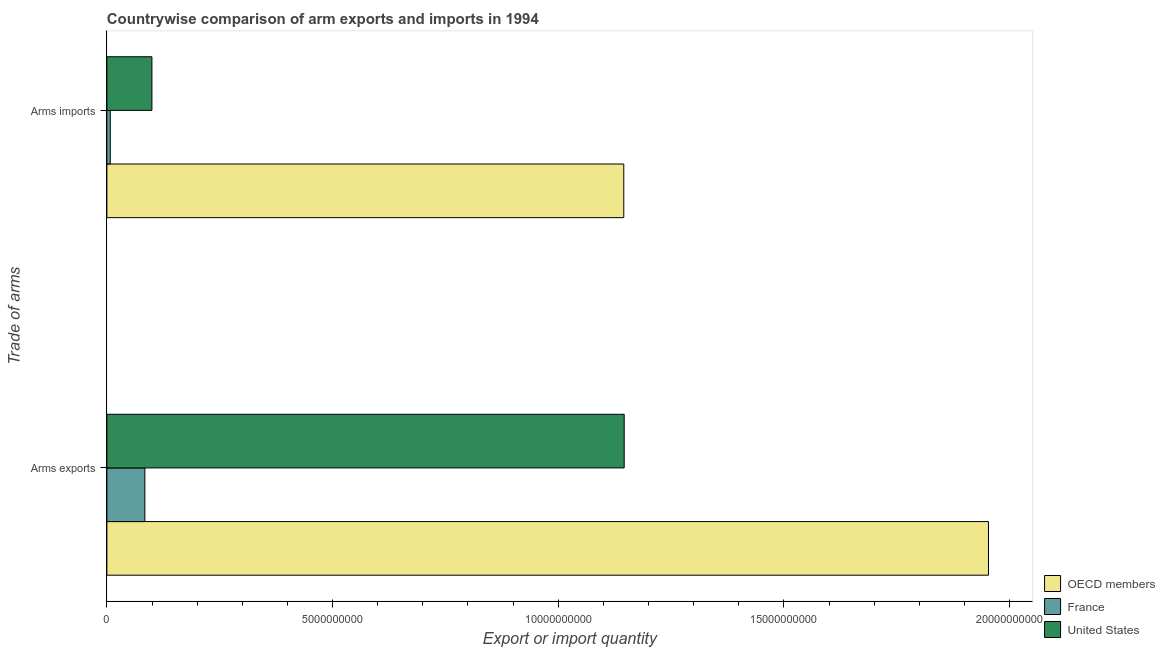How many different coloured bars are there?
Keep it short and to the point. 3. How many groups of bars are there?
Ensure brevity in your answer.  2. Are the number of bars per tick equal to the number of legend labels?
Your answer should be very brief. Yes. Are the number of bars on each tick of the Y-axis equal?
Offer a very short reply. Yes. What is the label of the 1st group of bars from the top?
Your answer should be very brief. Arms imports. What is the arms exports in OECD members?
Offer a very short reply. 1.95e+1. Across all countries, what is the maximum arms imports?
Your answer should be compact. 1.15e+1. Across all countries, what is the minimum arms imports?
Offer a terse response. 7.50e+07. In which country was the arms exports minimum?
Give a very brief answer. France. What is the total arms exports in the graph?
Ensure brevity in your answer.  3.18e+1. What is the difference between the arms imports in United States and that in France?
Your response must be concise. 9.23e+08. What is the difference between the arms exports in France and the arms imports in OECD members?
Your answer should be compact. -1.06e+1. What is the average arms imports per country?
Give a very brief answer. 4.18e+09. What is the difference between the arms exports and arms imports in United States?
Provide a succinct answer. 1.05e+1. What is the ratio of the arms exports in United States to that in OECD members?
Your answer should be compact. 0.59. Is the arms imports in United States less than that in France?
Offer a very short reply. No. In how many countries, is the arms exports greater than the average arms exports taken over all countries?
Give a very brief answer. 2. What does the 2nd bar from the bottom in Arms exports represents?
Your answer should be compact. France. Are all the bars in the graph horizontal?
Provide a short and direct response. Yes. How many countries are there in the graph?
Your answer should be compact. 3. What is the difference between two consecutive major ticks on the X-axis?
Provide a short and direct response. 5.00e+09. Are the values on the major ticks of X-axis written in scientific E-notation?
Provide a short and direct response. No. Does the graph contain any zero values?
Provide a succinct answer. No. Does the graph contain grids?
Make the answer very short. No. How are the legend labels stacked?
Your answer should be compact. Vertical. What is the title of the graph?
Provide a succinct answer. Countrywise comparison of arm exports and imports in 1994. What is the label or title of the X-axis?
Give a very brief answer. Export or import quantity. What is the label or title of the Y-axis?
Your response must be concise. Trade of arms. What is the Export or import quantity of OECD members in Arms exports?
Provide a short and direct response. 1.95e+1. What is the Export or import quantity in France in Arms exports?
Provide a short and direct response. 8.42e+08. What is the Export or import quantity of United States in Arms exports?
Your response must be concise. 1.15e+1. What is the Export or import quantity in OECD members in Arms imports?
Your answer should be very brief. 1.15e+1. What is the Export or import quantity of France in Arms imports?
Your response must be concise. 7.50e+07. What is the Export or import quantity of United States in Arms imports?
Make the answer very short. 9.98e+08. Across all Trade of arms, what is the maximum Export or import quantity in OECD members?
Provide a succinct answer. 1.95e+1. Across all Trade of arms, what is the maximum Export or import quantity in France?
Make the answer very short. 8.42e+08. Across all Trade of arms, what is the maximum Export or import quantity in United States?
Your answer should be compact. 1.15e+1. Across all Trade of arms, what is the minimum Export or import quantity in OECD members?
Ensure brevity in your answer.  1.15e+1. Across all Trade of arms, what is the minimum Export or import quantity in France?
Offer a terse response. 7.50e+07. Across all Trade of arms, what is the minimum Export or import quantity of United States?
Keep it short and to the point. 9.98e+08. What is the total Export or import quantity in OECD members in the graph?
Your answer should be very brief. 3.10e+1. What is the total Export or import quantity in France in the graph?
Give a very brief answer. 9.17e+08. What is the total Export or import quantity of United States in the graph?
Give a very brief answer. 1.25e+1. What is the difference between the Export or import quantity of OECD members in Arms exports and that in Arms imports?
Offer a very short reply. 8.08e+09. What is the difference between the Export or import quantity of France in Arms exports and that in Arms imports?
Your answer should be compact. 7.67e+08. What is the difference between the Export or import quantity of United States in Arms exports and that in Arms imports?
Offer a terse response. 1.05e+1. What is the difference between the Export or import quantity of OECD members in Arms exports and the Export or import quantity of France in Arms imports?
Offer a terse response. 1.95e+1. What is the difference between the Export or import quantity of OECD members in Arms exports and the Export or import quantity of United States in Arms imports?
Provide a short and direct response. 1.85e+1. What is the difference between the Export or import quantity of France in Arms exports and the Export or import quantity of United States in Arms imports?
Your answer should be compact. -1.56e+08. What is the average Export or import quantity in OECD members per Trade of arms?
Make the answer very short. 1.55e+1. What is the average Export or import quantity in France per Trade of arms?
Offer a very short reply. 4.58e+08. What is the average Export or import quantity in United States per Trade of arms?
Ensure brevity in your answer.  6.23e+09. What is the difference between the Export or import quantity of OECD members and Export or import quantity of France in Arms exports?
Offer a very short reply. 1.87e+1. What is the difference between the Export or import quantity of OECD members and Export or import quantity of United States in Arms exports?
Provide a succinct answer. 8.07e+09. What is the difference between the Export or import quantity in France and Export or import quantity in United States in Arms exports?
Your response must be concise. -1.06e+1. What is the difference between the Export or import quantity of OECD members and Export or import quantity of France in Arms imports?
Your answer should be very brief. 1.14e+1. What is the difference between the Export or import quantity of OECD members and Export or import quantity of United States in Arms imports?
Provide a short and direct response. 1.05e+1. What is the difference between the Export or import quantity of France and Export or import quantity of United States in Arms imports?
Give a very brief answer. -9.23e+08. What is the ratio of the Export or import quantity of OECD members in Arms exports to that in Arms imports?
Offer a very short reply. 1.71. What is the ratio of the Export or import quantity of France in Arms exports to that in Arms imports?
Give a very brief answer. 11.23. What is the ratio of the Export or import quantity of United States in Arms exports to that in Arms imports?
Offer a very short reply. 11.48. What is the difference between the highest and the second highest Export or import quantity in OECD members?
Provide a succinct answer. 8.08e+09. What is the difference between the highest and the second highest Export or import quantity in France?
Your answer should be very brief. 7.67e+08. What is the difference between the highest and the second highest Export or import quantity of United States?
Ensure brevity in your answer.  1.05e+1. What is the difference between the highest and the lowest Export or import quantity in OECD members?
Provide a short and direct response. 8.08e+09. What is the difference between the highest and the lowest Export or import quantity in France?
Your answer should be compact. 7.67e+08. What is the difference between the highest and the lowest Export or import quantity in United States?
Offer a very short reply. 1.05e+1. 